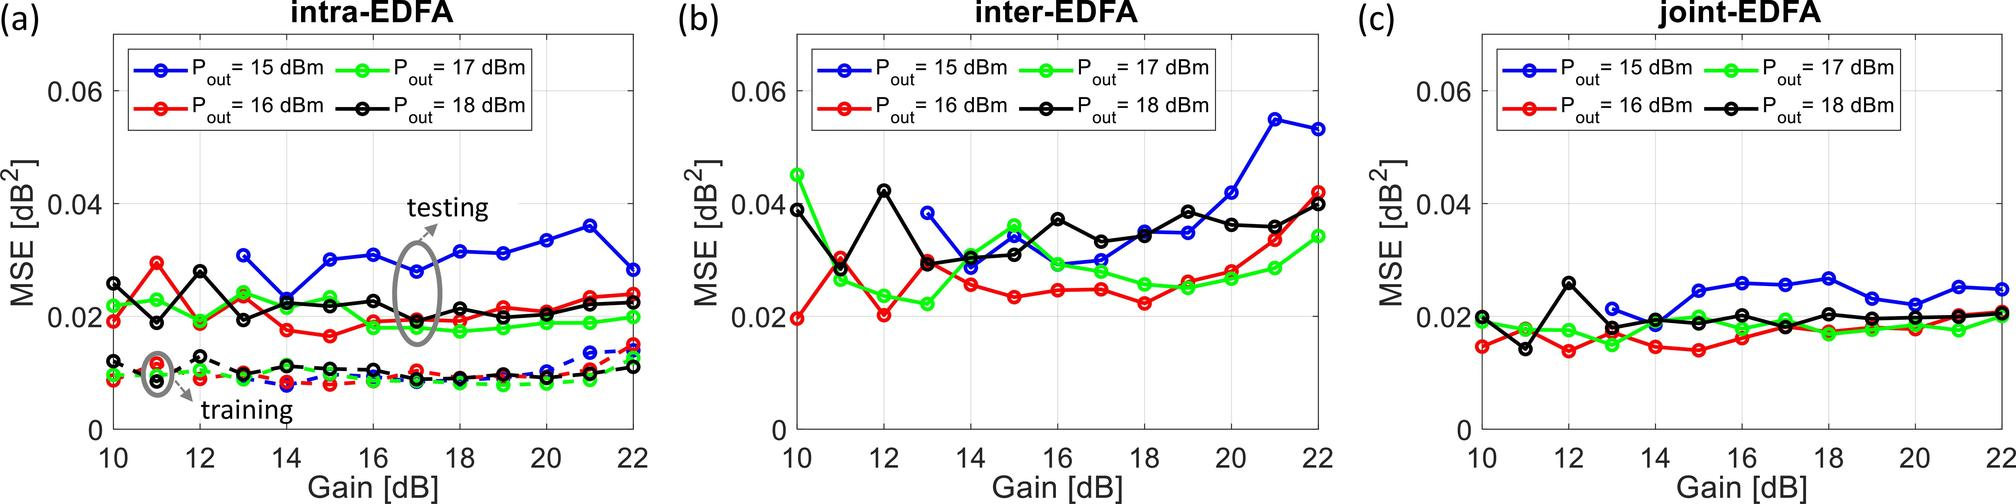What is a common trend observed in the Mean Squared Error (MSE) as the gain increases in the intra-EDFA configuration for different output powers in Figure (a)? MSE decreases consistently as the gain increases. MSE increases consistently as the gain increases. MSE initially decreases and then stabilizes as the gain increases. There is no observable trend in the MSE with the increase in gain. The figure shows that for the intra-EDFA configuration, the MSE decreases as the gain increases from 10 dB and then tends to stabilize or slightly fluctuate without a clear increasing or decreasing trend. This is indicated by the leveling off of the MSE values for gains above 16 dB for all output power levels. Therefore, the correct answer is C. 